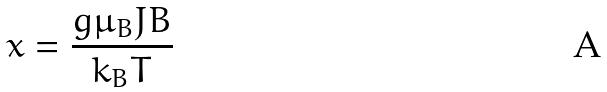Convert formula to latex. <formula><loc_0><loc_0><loc_500><loc_500>x = \frac { g \mu _ { B } J B } { k _ { B } T }</formula> 